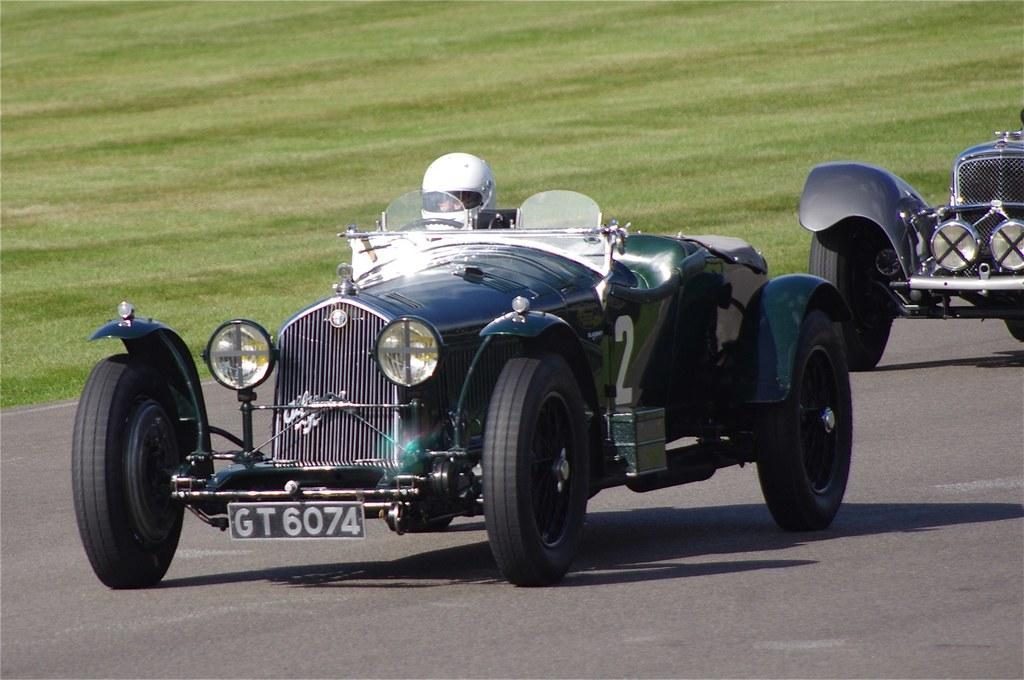What can be seen on the road in the image? There are vehicles on the road in the image. Can you describe the people or objects inside the vehicles? There is at least one person visible inside a vehicle. What is the temperature inside the office in the image? There is no office present in the image; it features vehicles on the road. 